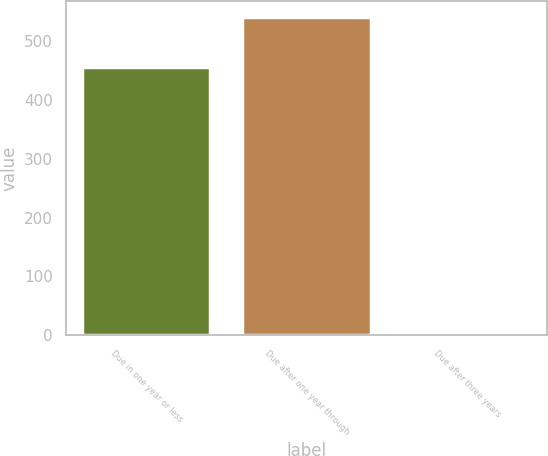<chart> <loc_0><loc_0><loc_500><loc_500><bar_chart><fcel>Due in one year or less<fcel>Due after one year through<fcel>Due after three years<nl><fcel>456.1<fcel>540.7<fcel>1.4<nl></chart> 